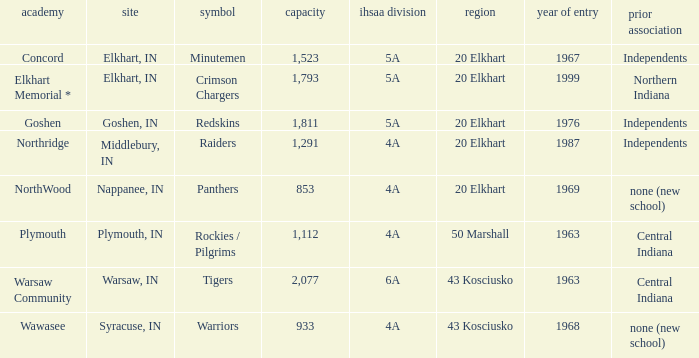What is the IHSAA class for the team located in Middlebury, IN? 4A. 